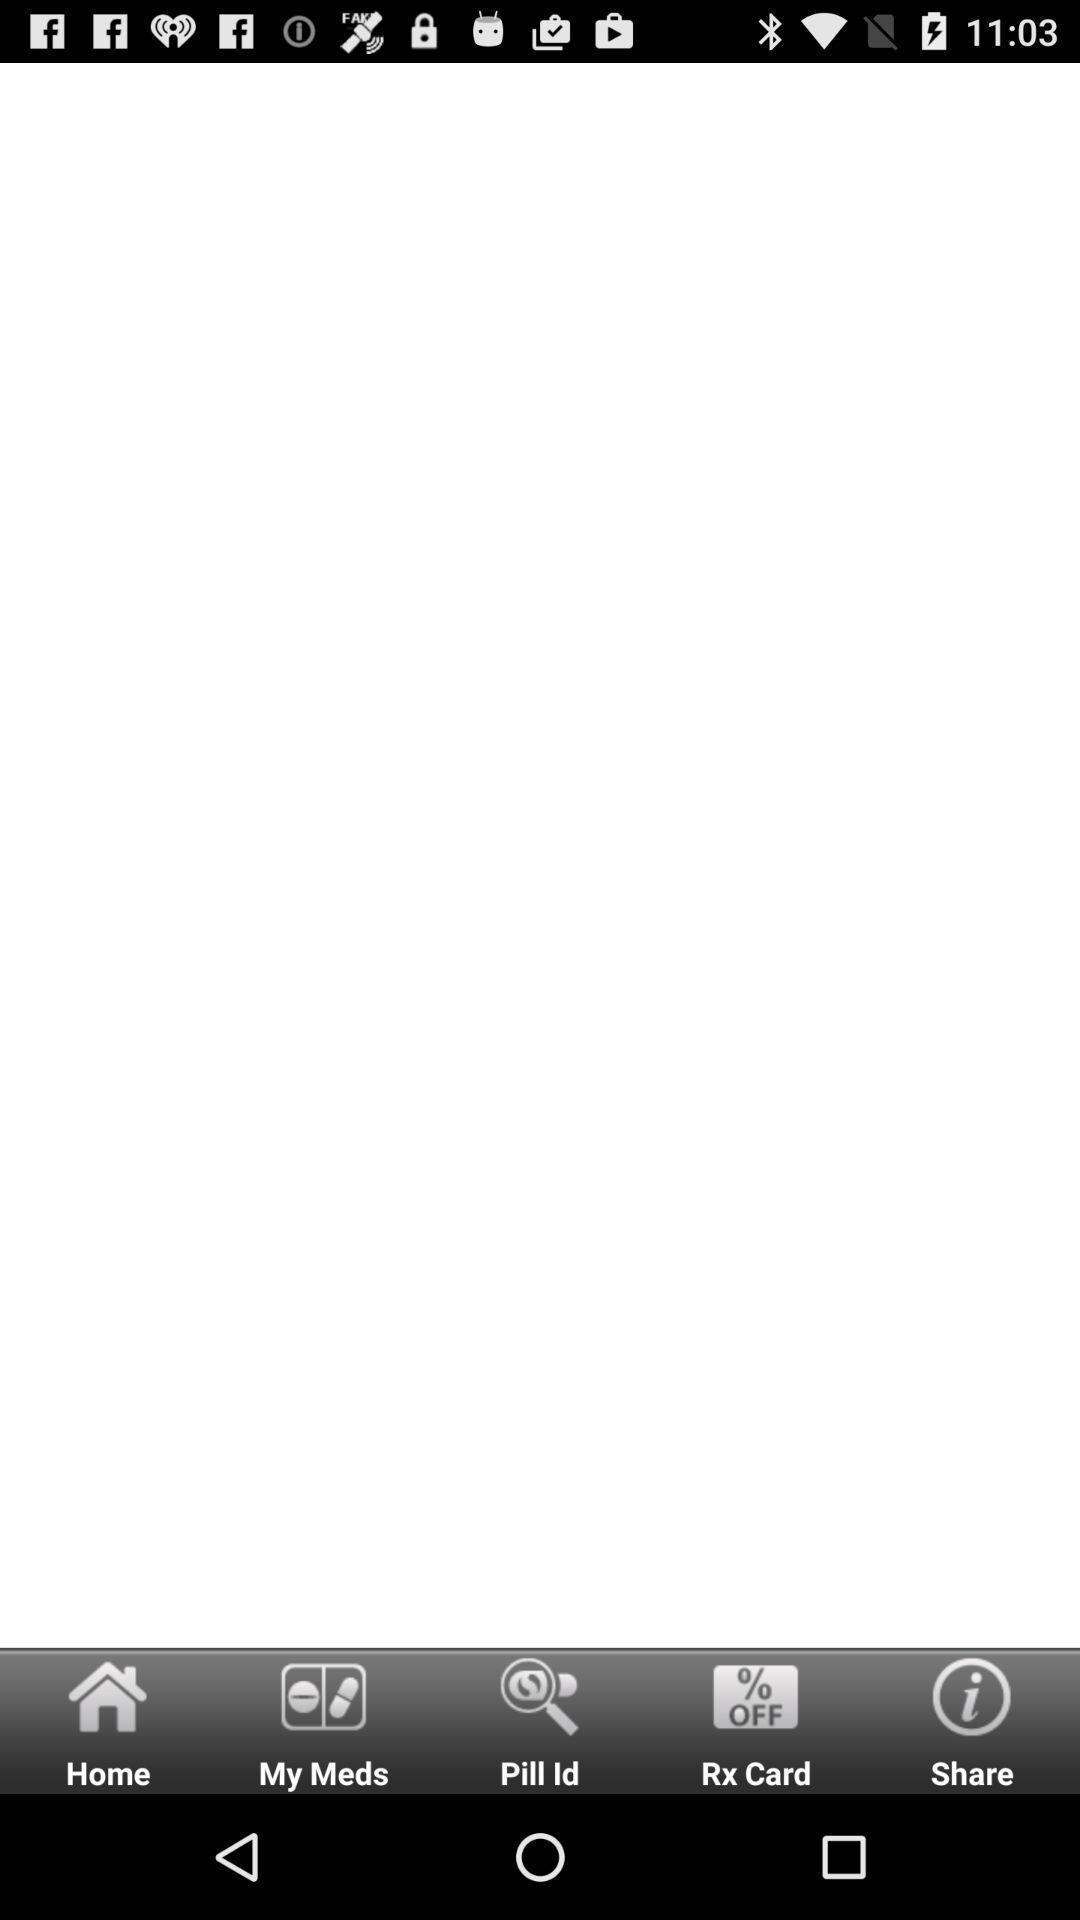Tell me about the visual elements in this screen capture. One of the page of medical app. 